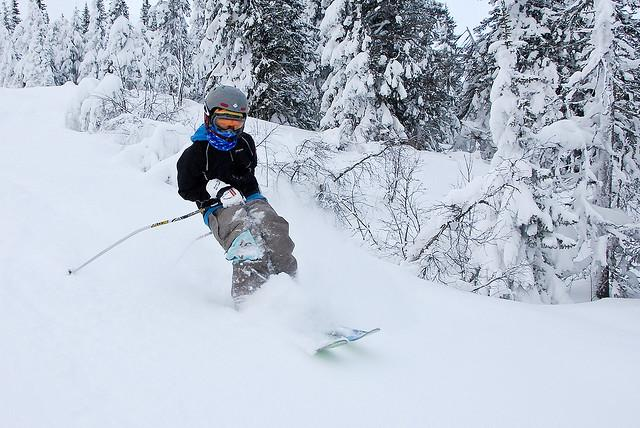Where might this child be located? Please explain your reasoning. colorado. The child is skiing in an area that is blanketed by snow. florida, texas, and most of california are too warm to get significant amounts of snow. 